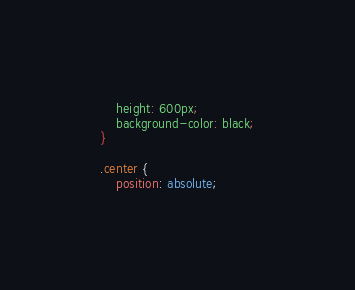<code> <loc_0><loc_0><loc_500><loc_500><_CSS_>    height: 600px;
    background-color: black;
}

.center {
    position: absolute;</code> 